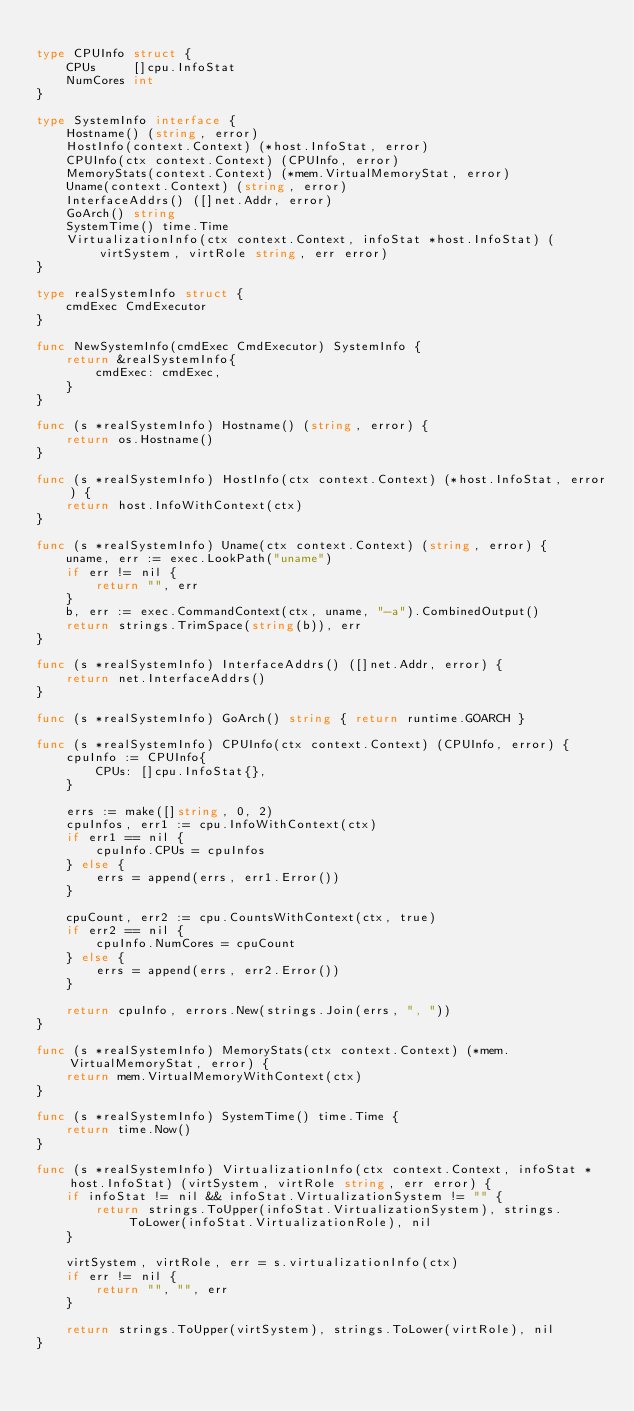Convert code to text. <code><loc_0><loc_0><loc_500><loc_500><_Go_>
type CPUInfo struct {
	CPUs     []cpu.InfoStat
	NumCores int
}

type SystemInfo interface {
	Hostname() (string, error)
	HostInfo(context.Context) (*host.InfoStat, error)
	CPUInfo(ctx context.Context) (CPUInfo, error)
	MemoryStats(context.Context) (*mem.VirtualMemoryStat, error)
	Uname(context.Context) (string, error)
	InterfaceAddrs() ([]net.Addr, error)
	GoArch() string
	SystemTime() time.Time
	VirtualizationInfo(ctx context.Context, infoStat *host.InfoStat) (virtSystem, virtRole string, err error)
}

type realSystemInfo struct {
	cmdExec CmdExecutor
}

func NewSystemInfo(cmdExec CmdExecutor) SystemInfo {
	return &realSystemInfo{
		cmdExec: cmdExec,
	}
}

func (s *realSystemInfo) Hostname() (string, error) {
	return os.Hostname()
}

func (s *realSystemInfo) HostInfo(ctx context.Context) (*host.InfoStat, error) {
	return host.InfoWithContext(ctx)
}

func (s *realSystemInfo) Uname(ctx context.Context) (string, error) {
	uname, err := exec.LookPath("uname")
	if err != nil {
		return "", err
	}
	b, err := exec.CommandContext(ctx, uname, "-a").CombinedOutput()
	return strings.TrimSpace(string(b)), err
}

func (s *realSystemInfo) InterfaceAddrs() ([]net.Addr, error) {
	return net.InterfaceAddrs()
}

func (s *realSystemInfo) GoArch() string { return runtime.GOARCH }

func (s *realSystemInfo) CPUInfo(ctx context.Context) (CPUInfo, error) {
	cpuInfo := CPUInfo{
		CPUs: []cpu.InfoStat{},
	}

	errs := make([]string, 0, 2)
	cpuInfos, err1 := cpu.InfoWithContext(ctx)
	if err1 == nil {
		cpuInfo.CPUs = cpuInfos
	} else {
		errs = append(errs, err1.Error())
	}

	cpuCount, err2 := cpu.CountsWithContext(ctx, true)
	if err2 == nil {
		cpuInfo.NumCores = cpuCount
	} else {
		errs = append(errs, err2.Error())
	}

	return cpuInfo, errors.New(strings.Join(errs, ", "))
}

func (s *realSystemInfo) MemoryStats(ctx context.Context) (*mem.VirtualMemoryStat, error) {
	return mem.VirtualMemoryWithContext(ctx)
}

func (s *realSystemInfo) SystemTime() time.Time {
	return time.Now()
}

func (s *realSystemInfo) VirtualizationInfo(ctx context.Context, infoStat *host.InfoStat) (virtSystem, virtRole string, err error) {
	if infoStat != nil && infoStat.VirtualizationSystem != "" {
		return strings.ToUpper(infoStat.VirtualizationSystem), strings.ToLower(infoStat.VirtualizationRole), nil
	}

	virtSystem, virtRole, err = s.virtualizationInfo(ctx)
	if err != nil {
		return "", "", err
	}

	return strings.ToUpper(virtSystem), strings.ToLower(virtRole), nil
}
</code> 